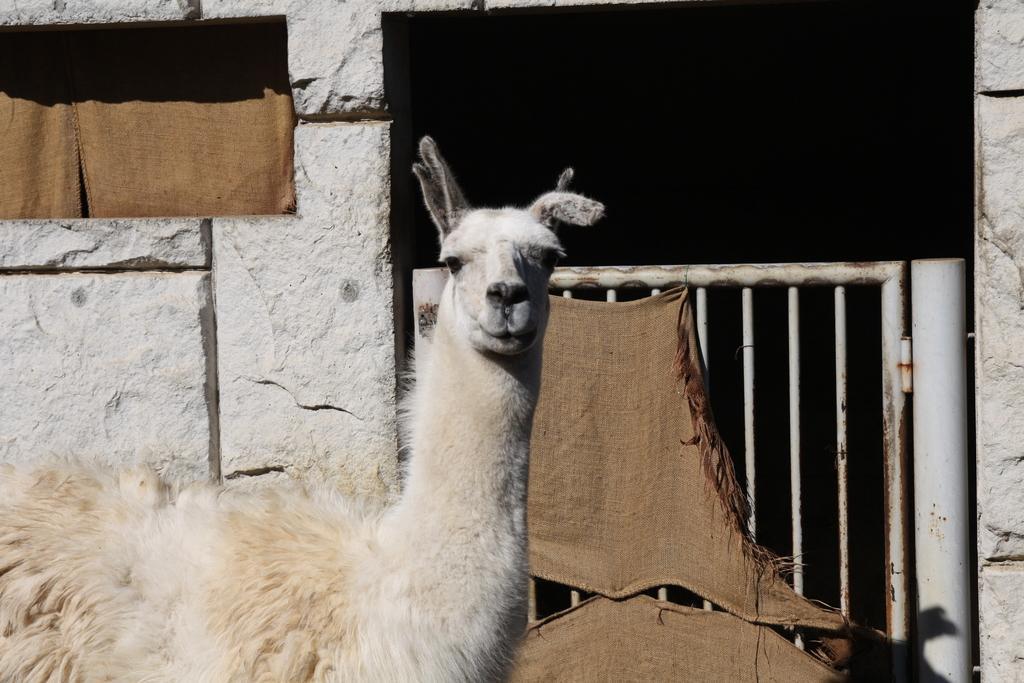Could you give a brief overview of what you see in this image? In this image there is an animal looking at someone and on the right side there is the gate. 